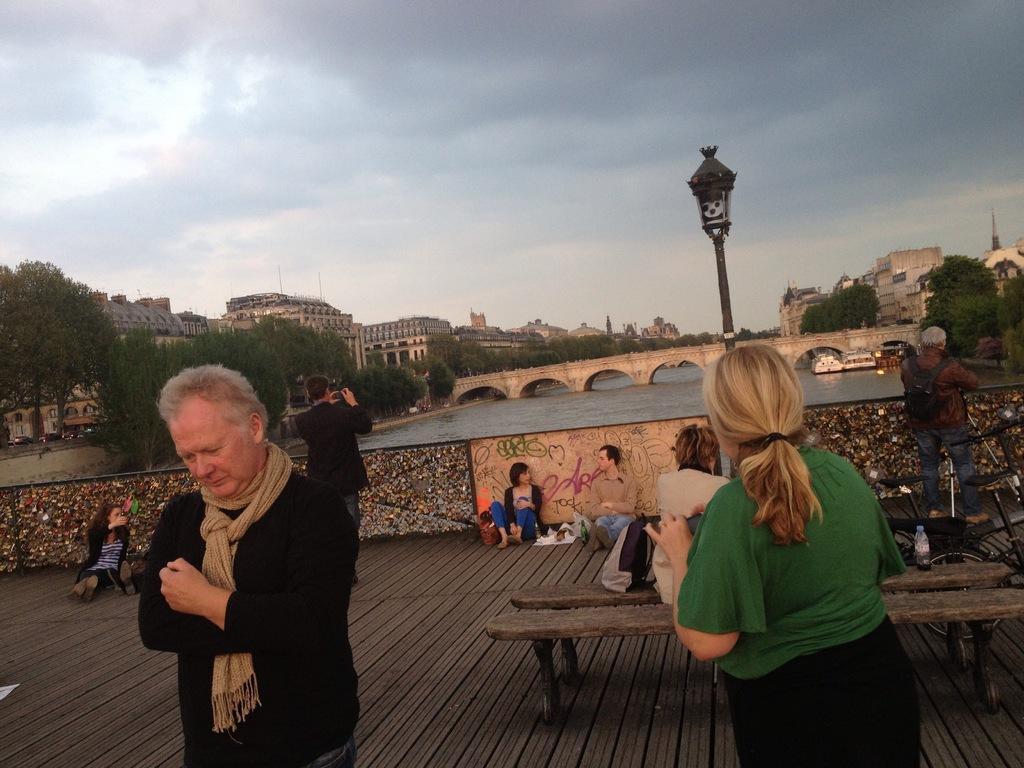Could you give a brief overview of what you see in this image? In the picture we can see some group of persons standing and some are sitting on floor and there is water, in the background of the picture there is bridge, there are some trees, buildings on left and right side of the picture and top of the picture there is cloudy sky. 